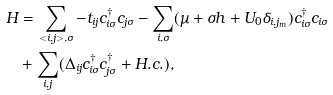<formula> <loc_0><loc_0><loc_500><loc_500>H & = \sum _ { < i , j > , \sigma } - t _ { i j } c ^ { \dagger } _ { i \sigma } c _ { j \sigma } - \sum _ { i , \sigma } ( \mu + \sigma h + U _ { 0 } \delta _ { i , j _ { m } } ) c ^ { \dagger } _ { i \sigma } c _ { i \sigma } \\ & + \sum _ { i , j } ( \Delta _ { i j } c ^ { \dagger } _ { i \sigma } c _ { j \sigma } ^ { \dagger } + H . c . ) ,</formula> 